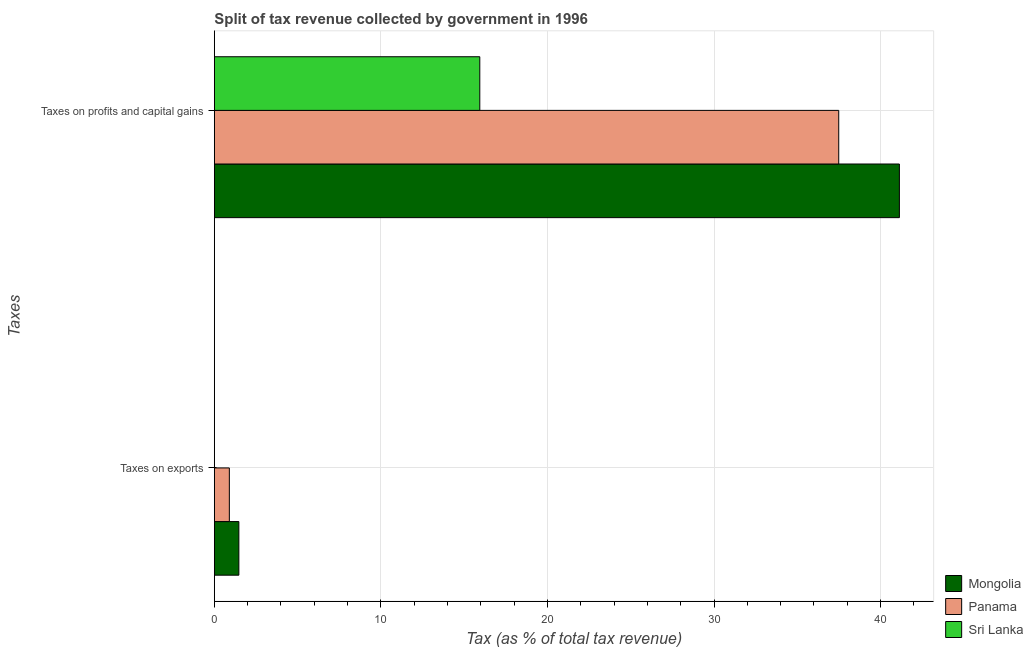How many bars are there on the 2nd tick from the top?
Your answer should be compact. 3. What is the label of the 2nd group of bars from the top?
Your answer should be very brief. Taxes on exports. What is the percentage of revenue obtained from taxes on exports in Sri Lanka?
Keep it short and to the point. 0. Across all countries, what is the maximum percentage of revenue obtained from taxes on exports?
Ensure brevity in your answer.  1.47. Across all countries, what is the minimum percentage of revenue obtained from taxes on exports?
Offer a terse response. 0. In which country was the percentage of revenue obtained from taxes on exports maximum?
Keep it short and to the point. Mongolia. In which country was the percentage of revenue obtained from taxes on exports minimum?
Keep it short and to the point. Sri Lanka. What is the total percentage of revenue obtained from taxes on exports in the graph?
Offer a very short reply. 2.38. What is the difference between the percentage of revenue obtained from taxes on exports in Sri Lanka and that in Mongolia?
Your response must be concise. -1.47. What is the difference between the percentage of revenue obtained from taxes on exports in Mongolia and the percentage of revenue obtained from taxes on profits and capital gains in Panama?
Offer a terse response. -36.02. What is the average percentage of revenue obtained from taxes on profits and capital gains per country?
Offer a very short reply. 31.52. What is the difference between the percentage of revenue obtained from taxes on profits and capital gains and percentage of revenue obtained from taxes on exports in Panama?
Provide a short and direct response. 36.59. In how many countries, is the percentage of revenue obtained from taxes on exports greater than 34 %?
Your answer should be compact. 0. What is the ratio of the percentage of revenue obtained from taxes on profits and capital gains in Mongolia to that in Panama?
Give a very brief answer. 1.1. In how many countries, is the percentage of revenue obtained from taxes on profits and capital gains greater than the average percentage of revenue obtained from taxes on profits and capital gains taken over all countries?
Make the answer very short. 2. What does the 3rd bar from the top in Taxes on exports represents?
Your answer should be compact. Mongolia. What does the 3rd bar from the bottom in Taxes on exports represents?
Your answer should be very brief. Sri Lanka. How many countries are there in the graph?
Your response must be concise. 3. What is the difference between two consecutive major ticks on the X-axis?
Provide a short and direct response. 10. Are the values on the major ticks of X-axis written in scientific E-notation?
Provide a succinct answer. No. Does the graph contain grids?
Ensure brevity in your answer.  Yes. Where does the legend appear in the graph?
Provide a succinct answer. Bottom right. What is the title of the graph?
Offer a terse response. Split of tax revenue collected by government in 1996. Does "Sudan" appear as one of the legend labels in the graph?
Give a very brief answer. No. What is the label or title of the X-axis?
Offer a terse response. Tax (as % of total tax revenue). What is the label or title of the Y-axis?
Provide a succinct answer. Taxes. What is the Tax (as % of total tax revenue) in Mongolia in Taxes on exports?
Make the answer very short. 1.47. What is the Tax (as % of total tax revenue) in Panama in Taxes on exports?
Ensure brevity in your answer.  0.9. What is the Tax (as % of total tax revenue) of Sri Lanka in Taxes on exports?
Give a very brief answer. 0. What is the Tax (as % of total tax revenue) of Mongolia in Taxes on profits and capital gains?
Your answer should be very brief. 41.13. What is the Tax (as % of total tax revenue) of Panama in Taxes on profits and capital gains?
Your answer should be very brief. 37.49. What is the Tax (as % of total tax revenue) in Sri Lanka in Taxes on profits and capital gains?
Your answer should be very brief. 15.94. Across all Taxes, what is the maximum Tax (as % of total tax revenue) in Mongolia?
Provide a succinct answer. 41.13. Across all Taxes, what is the maximum Tax (as % of total tax revenue) in Panama?
Provide a short and direct response. 37.49. Across all Taxes, what is the maximum Tax (as % of total tax revenue) in Sri Lanka?
Provide a succinct answer. 15.94. Across all Taxes, what is the minimum Tax (as % of total tax revenue) in Mongolia?
Keep it short and to the point. 1.47. Across all Taxes, what is the minimum Tax (as % of total tax revenue) of Panama?
Offer a terse response. 0.9. Across all Taxes, what is the minimum Tax (as % of total tax revenue) in Sri Lanka?
Keep it short and to the point. 0. What is the total Tax (as % of total tax revenue) in Mongolia in the graph?
Make the answer very short. 42.6. What is the total Tax (as % of total tax revenue) in Panama in the graph?
Keep it short and to the point. 38.39. What is the total Tax (as % of total tax revenue) of Sri Lanka in the graph?
Provide a succinct answer. 15.94. What is the difference between the Tax (as % of total tax revenue) in Mongolia in Taxes on exports and that in Taxes on profits and capital gains?
Ensure brevity in your answer.  -39.66. What is the difference between the Tax (as % of total tax revenue) of Panama in Taxes on exports and that in Taxes on profits and capital gains?
Keep it short and to the point. -36.59. What is the difference between the Tax (as % of total tax revenue) in Sri Lanka in Taxes on exports and that in Taxes on profits and capital gains?
Your answer should be very brief. -15.93. What is the difference between the Tax (as % of total tax revenue) in Mongolia in Taxes on exports and the Tax (as % of total tax revenue) in Panama in Taxes on profits and capital gains?
Offer a very short reply. -36.02. What is the difference between the Tax (as % of total tax revenue) in Mongolia in Taxes on exports and the Tax (as % of total tax revenue) in Sri Lanka in Taxes on profits and capital gains?
Your answer should be very brief. -14.47. What is the difference between the Tax (as % of total tax revenue) in Panama in Taxes on exports and the Tax (as % of total tax revenue) in Sri Lanka in Taxes on profits and capital gains?
Provide a succinct answer. -15.04. What is the average Tax (as % of total tax revenue) in Mongolia per Taxes?
Provide a succinct answer. 21.3. What is the average Tax (as % of total tax revenue) of Panama per Taxes?
Offer a very short reply. 19.19. What is the average Tax (as % of total tax revenue) of Sri Lanka per Taxes?
Your answer should be compact. 7.97. What is the difference between the Tax (as % of total tax revenue) of Mongolia and Tax (as % of total tax revenue) of Panama in Taxes on exports?
Your answer should be very brief. 0.57. What is the difference between the Tax (as % of total tax revenue) in Mongolia and Tax (as % of total tax revenue) in Sri Lanka in Taxes on exports?
Offer a terse response. 1.47. What is the difference between the Tax (as % of total tax revenue) of Panama and Tax (as % of total tax revenue) of Sri Lanka in Taxes on exports?
Keep it short and to the point. 0.9. What is the difference between the Tax (as % of total tax revenue) in Mongolia and Tax (as % of total tax revenue) in Panama in Taxes on profits and capital gains?
Give a very brief answer. 3.64. What is the difference between the Tax (as % of total tax revenue) of Mongolia and Tax (as % of total tax revenue) of Sri Lanka in Taxes on profits and capital gains?
Your answer should be very brief. 25.19. What is the difference between the Tax (as % of total tax revenue) in Panama and Tax (as % of total tax revenue) in Sri Lanka in Taxes on profits and capital gains?
Offer a terse response. 21.55. What is the ratio of the Tax (as % of total tax revenue) in Mongolia in Taxes on exports to that in Taxes on profits and capital gains?
Offer a terse response. 0.04. What is the ratio of the Tax (as % of total tax revenue) of Panama in Taxes on exports to that in Taxes on profits and capital gains?
Offer a terse response. 0.02. What is the difference between the highest and the second highest Tax (as % of total tax revenue) of Mongolia?
Provide a succinct answer. 39.66. What is the difference between the highest and the second highest Tax (as % of total tax revenue) in Panama?
Give a very brief answer. 36.59. What is the difference between the highest and the second highest Tax (as % of total tax revenue) of Sri Lanka?
Your response must be concise. 15.93. What is the difference between the highest and the lowest Tax (as % of total tax revenue) of Mongolia?
Ensure brevity in your answer.  39.66. What is the difference between the highest and the lowest Tax (as % of total tax revenue) in Panama?
Make the answer very short. 36.59. What is the difference between the highest and the lowest Tax (as % of total tax revenue) in Sri Lanka?
Give a very brief answer. 15.93. 